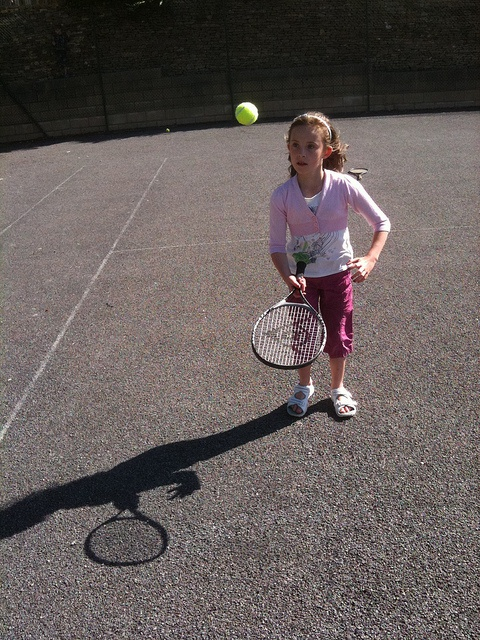Describe the objects in this image and their specific colors. I can see people in black, gray, and maroon tones, tennis racket in black, darkgray, gray, and lightgray tones, and sports ball in black, ivory, olive, and khaki tones in this image. 